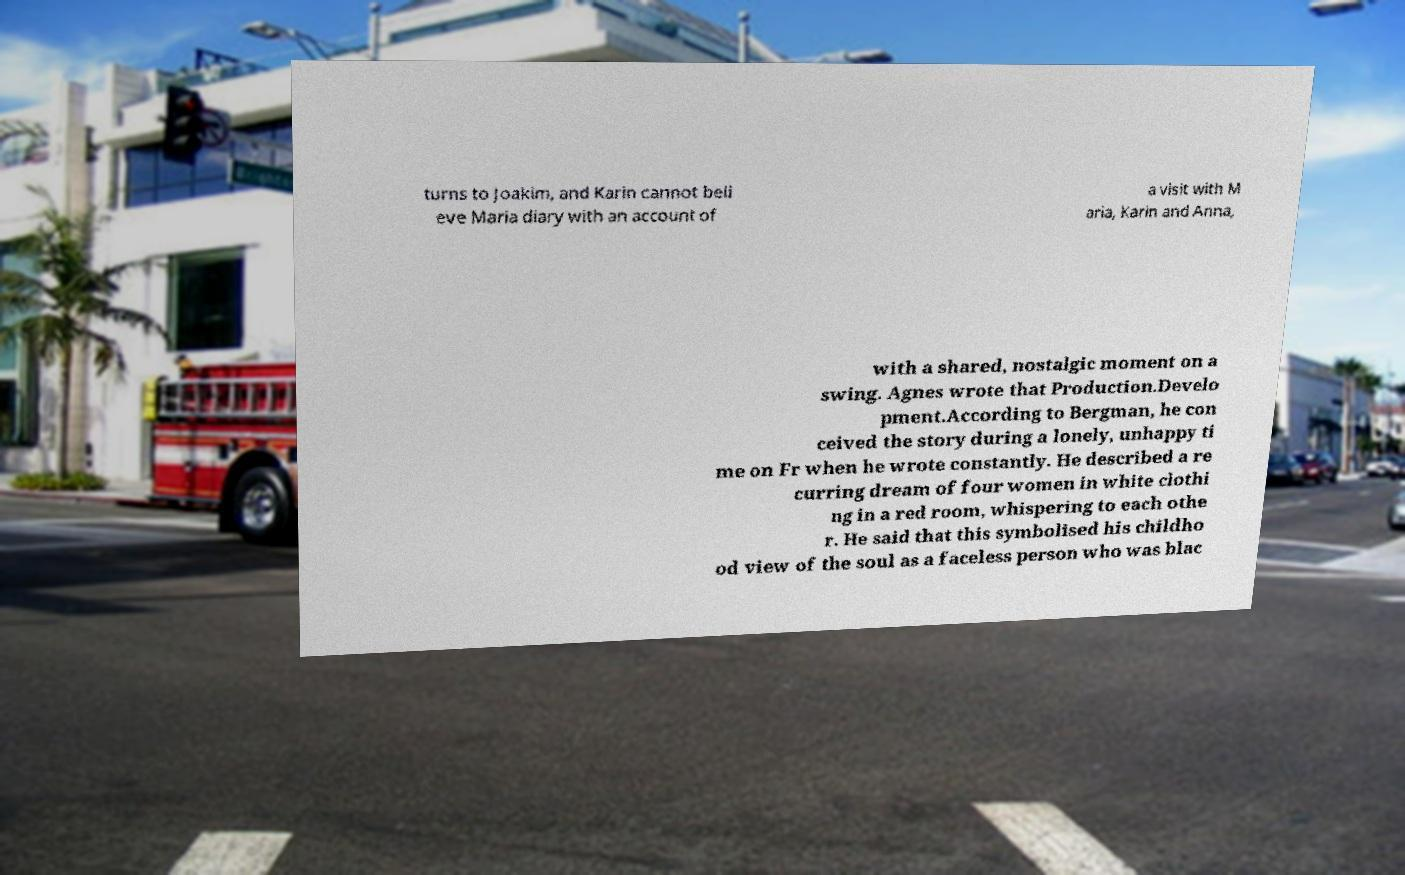Can you read and provide the text displayed in the image?This photo seems to have some interesting text. Can you extract and type it out for me? turns to Joakim, and Karin cannot beli eve Maria diary with an account of a visit with M aria, Karin and Anna, with a shared, nostalgic moment on a swing. Agnes wrote that Production.Develo pment.According to Bergman, he con ceived the story during a lonely, unhappy ti me on Fr when he wrote constantly. He described a re curring dream of four women in white clothi ng in a red room, whispering to each othe r. He said that this symbolised his childho od view of the soul as a faceless person who was blac 